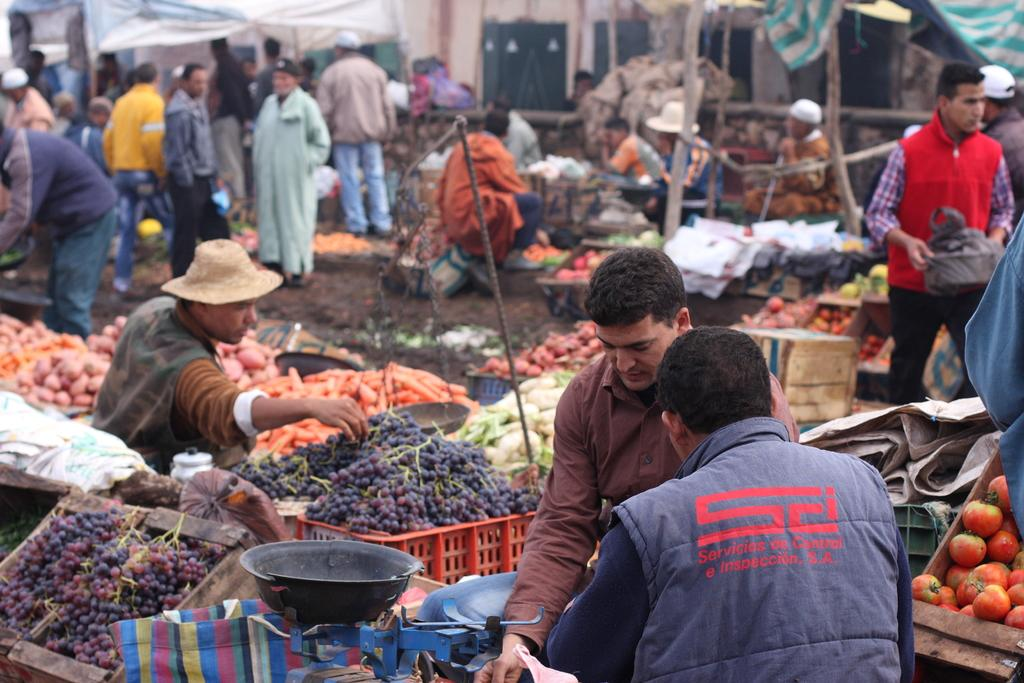What type of location is depicted in the image? The image depicts a market. What types of food items are being sold in the market? There are many fruits and vegetables being sold in the market. What can be observed about the people in the image? There are people walking around the market. How many feet are visible in the image? There is no specific mention of feet in the image, so it is not possible to determine how many are visible. 